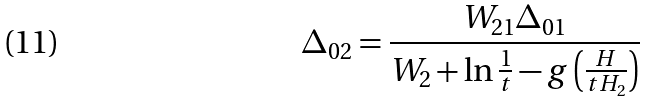<formula> <loc_0><loc_0><loc_500><loc_500>\Delta _ { 0 2 } = \frac { W _ { 2 1 } \Delta _ { 0 1 } } { W _ { 2 } + \ln \frac { 1 } { t } - g \left ( \frac { H } { t H _ { 2 } } \right ) }</formula> 